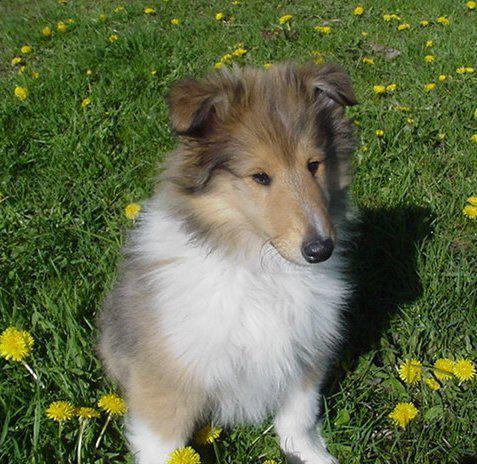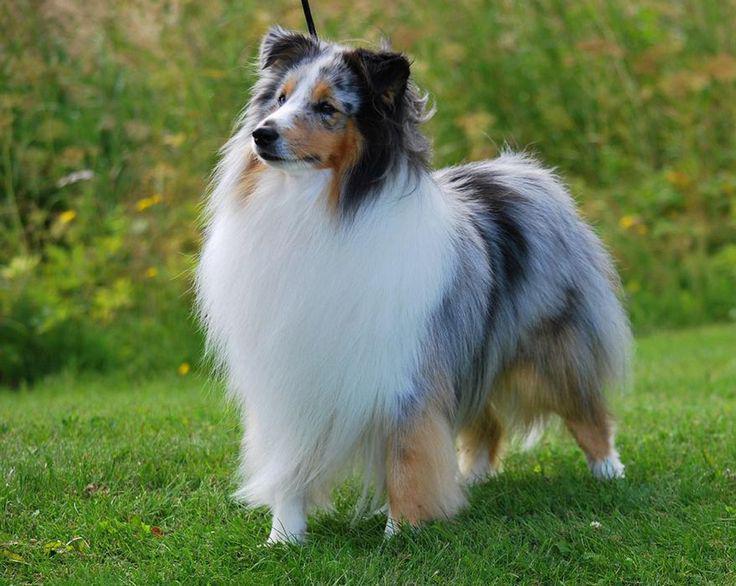The first image is the image on the left, the second image is the image on the right. Examine the images to the left and right. Is the description "both collies are standing and facing left" accurate? Answer yes or no. No. 